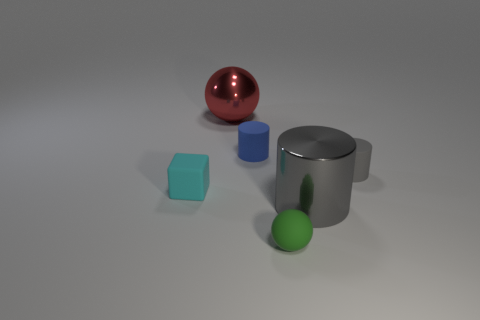Subtract all rubber cylinders. How many cylinders are left? 1 Add 2 big brown shiny spheres. How many objects exist? 8 Subtract all blue cylinders. How many cylinders are left? 2 Subtract all cubes. How many objects are left? 5 Subtract all cyan balls. How many gray cylinders are left? 2 Add 5 yellow metallic cylinders. How many yellow metallic cylinders exist? 5 Subtract 0 yellow cylinders. How many objects are left? 6 Subtract 2 cylinders. How many cylinders are left? 1 Subtract all blue spheres. Subtract all green blocks. How many spheres are left? 2 Subtract all large brown rubber blocks. Subtract all tiny matte things. How many objects are left? 2 